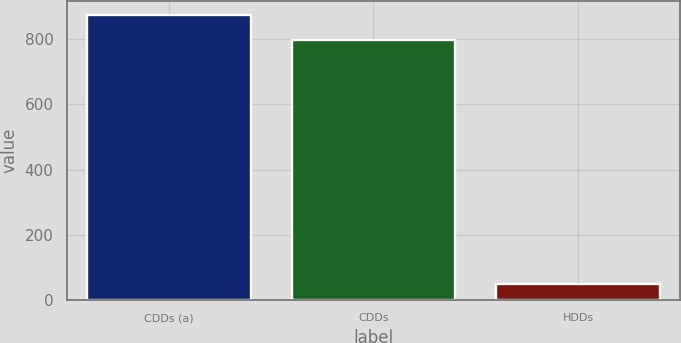<chart> <loc_0><loc_0><loc_500><loc_500><bar_chart><fcel>CDDs (a)<fcel>CDDs<fcel>HDDs<nl><fcel>873.7<fcel>798<fcel>49<nl></chart> 